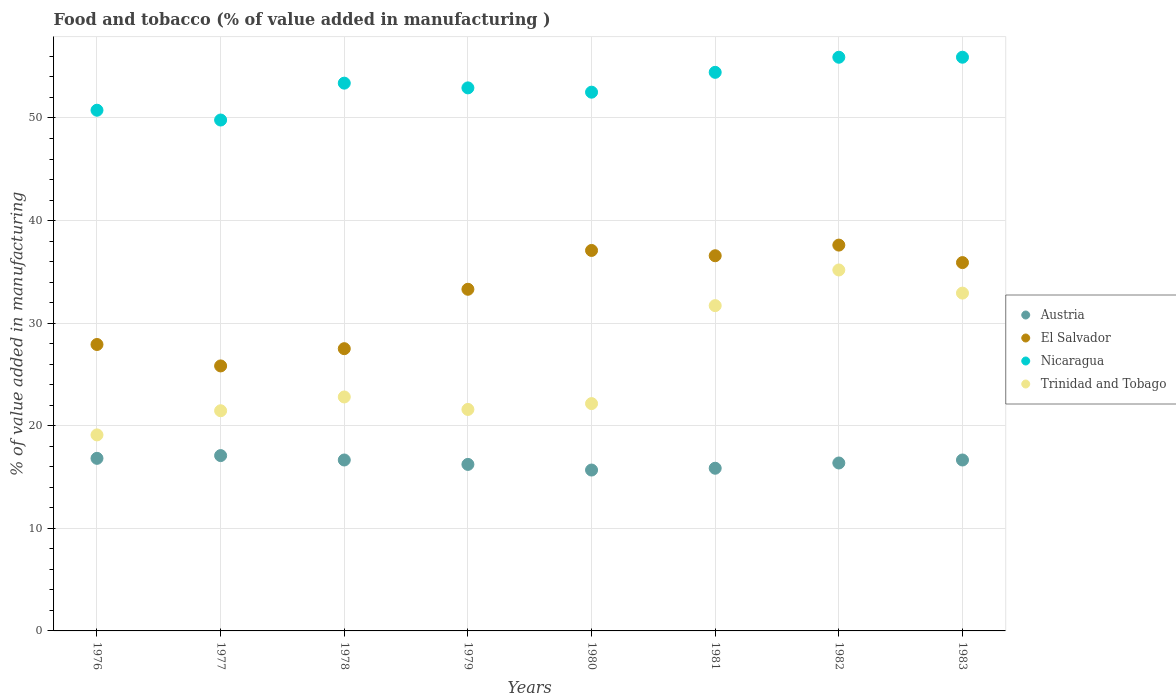How many different coloured dotlines are there?
Ensure brevity in your answer.  4. What is the value added in manufacturing food and tobacco in Austria in 1976?
Provide a short and direct response. 16.82. Across all years, what is the maximum value added in manufacturing food and tobacco in El Salvador?
Your response must be concise. 37.61. Across all years, what is the minimum value added in manufacturing food and tobacco in Nicaragua?
Your answer should be compact. 49.8. What is the total value added in manufacturing food and tobacco in Nicaragua in the graph?
Keep it short and to the point. 425.69. What is the difference between the value added in manufacturing food and tobacco in Austria in 1980 and that in 1983?
Your response must be concise. -0.98. What is the difference between the value added in manufacturing food and tobacco in Austria in 1980 and the value added in manufacturing food and tobacco in El Salvador in 1976?
Make the answer very short. -12.24. What is the average value added in manufacturing food and tobacco in El Salvador per year?
Your answer should be compact. 32.72. In the year 1981, what is the difference between the value added in manufacturing food and tobacco in Austria and value added in manufacturing food and tobacco in Trinidad and Tobago?
Your response must be concise. -15.85. In how many years, is the value added in manufacturing food and tobacco in El Salvador greater than 28 %?
Your response must be concise. 5. What is the ratio of the value added in manufacturing food and tobacco in El Salvador in 1976 to that in 1979?
Your answer should be compact. 0.84. Is the value added in manufacturing food and tobacco in El Salvador in 1981 less than that in 1982?
Make the answer very short. Yes. What is the difference between the highest and the second highest value added in manufacturing food and tobacco in Austria?
Keep it short and to the point. 0.27. What is the difference between the highest and the lowest value added in manufacturing food and tobacco in Austria?
Offer a terse response. 1.41. Is the sum of the value added in manufacturing food and tobacco in Austria in 1982 and 1983 greater than the maximum value added in manufacturing food and tobacco in El Salvador across all years?
Your answer should be compact. No. Does the value added in manufacturing food and tobacco in El Salvador monotonically increase over the years?
Offer a very short reply. No. How many dotlines are there?
Your response must be concise. 4. What is the difference between two consecutive major ticks on the Y-axis?
Your answer should be compact. 10. Are the values on the major ticks of Y-axis written in scientific E-notation?
Your answer should be very brief. No. Does the graph contain grids?
Offer a terse response. Yes. Where does the legend appear in the graph?
Offer a terse response. Center right. How many legend labels are there?
Ensure brevity in your answer.  4. How are the legend labels stacked?
Provide a short and direct response. Vertical. What is the title of the graph?
Your response must be concise. Food and tobacco (% of value added in manufacturing ). What is the label or title of the Y-axis?
Ensure brevity in your answer.  % of value added in manufacturing. What is the % of value added in manufacturing of Austria in 1976?
Ensure brevity in your answer.  16.82. What is the % of value added in manufacturing of El Salvador in 1976?
Provide a succinct answer. 27.92. What is the % of value added in manufacturing of Nicaragua in 1976?
Offer a very short reply. 50.76. What is the % of value added in manufacturing of Trinidad and Tobago in 1976?
Ensure brevity in your answer.  19.11. What is the % of value added in manufacturing of Austria in 1977?
Make the answer very short. 17.09. What is the % of value added in manufacturing in El Salvador in 1977?
Offer a terse response. 25.83. What is the % of value added in manufacturing in Nicaragua in 1977?
Offer a terse response. 49.8. What is the % of value added in manufacturing of Trinidad and Tobago in 1977?
Ensure brevity in your answer.  21.46. What is the % of value added in manufacturing in Austria in 1978?
Your response must be concise. 16.66. What is the % of value added in manufacturing in El Salvador in 1978?
Give a very brief answer. 27.51. What is the % of value added in manufacturing in Nicaragua in 1978?
Offer a very short reply. 53.39. What is the % of value added in manufacturing of Trinidad and Tobago in 1978?
Your answer should be very brief. 22.81. What is the % of value added in manufacturing of Austria in 1979?
Offer a very short reply. 16.23. What is the % of value added in manufacturing of El Salvador in 1979?
Offer a very short reply. 33.3. What is the % of value added in manufacturing in Nicaragua in 1979?
Keep it short and to the point. 52.93. What is the % of value added in manufacturing of Trinidad and Tobago in 1979?
Provide a short and direct response. 21.59. What is the % of value added in manufacturing in Austria in 1980?
Offer a very short reply. 15.68. What is the % of value added in manufacturing in El Salvador in 1980?
Your answer should be very brief. 37.09. What is the % of value added in manufacturing of Nicaragua in 1980?
Provide a short and direct response. 52.51. What is the % of value added in manufacturing of Trinidad and Tobago in 1980?
Your answer should be compact. 22.16. What is the % of value added in manufacturing of Austria in 1981?
Make the answer very short. 15.86. What is the % of value added in manufacturing in El Salvador in 1981?
Provide a succinct answer. 36.57. What is the % of value added in manufacturing in Nicaragua in 1981?
Provide a short and direct response. 54.45. What is the % of value added in manufacturing in Trinidad and Tobago in 1981?
Offer a very short reply. 31.71. What is the % of value added in manufacturing in Austria in 1982?
Provide a succinct answer. 16.37. What is the % of value added in manufacturing in El Salvador in 1982?
Provide a succinct answer. 37.61. What is the % of value added in manufacturing in Nicaragua in 1982?
Keep it short and to the point. 55.92. What is the % of value added in manufacturing of Trinidad and Tobago in 1982?
Your answer should be compact. 35.18. What is the % of value added in manufacturing in Austria in 1983?
Offer a very short reply. 16.66. What is the % of value added in manufacturing in El Salvador in 1983?
Offer a terse response. 35.9. What is the % of value added in manufacturing of Nicaragua in 1983?
Your response must be concise. 55.92. What is the % of value added in manufacturing of Trinidad and Tobago in 1983?
Provide a short and direct response. 32.93. Across all years, what is the maximum % of value added in manufacturing in Austria?
Your answer should be compact. 17.09. Across all years, what is the maximum % of value added in manufacturing of El Salvador?
Provide a short and direct response. 37.61. Across all years, what is the maximum % of value added in manufacturing in Nicaragua?
Your response must be concise. 55.92. Across all years, what is the maximum % of value added in manufacturing of Trinidad and Tobago?
Provide a succinct answer. 35.18. Across all years, what is the minimum % of value added in manufacturing of Austria?
Offer a very short reply. 15.68. Across all years, what is the minimum % of value added in manufacturing of El Salvador?
Keep it short and to the point. 25.83. Across all years, what is the minimum % of value added in manufacturing of Nicaragua?
Offer a very short reply. 49.8. Across all years, what is the minimum % of value added in manufacturing in Trinidad and Tobago?
Give a very brief answer. 19.11. What is the total % of value added in manufacturing of Austria in the graph?
Your response must be concise. 131.38. What is the total % of value added in manufacturing of El Salvador in the graph?
Provide a succinct answer. 261.73. What is the total % of value added in manufacturing in Nicaragua in the graph?
Provide a succinct answer. 425.69. What is the total % of value added in manufacturing in Trinidad and Tobago in the graph?
Provide a succinct answer. 206.94. What is the difference between the % of value added in manufacturing of Austria in 1976 and that in 1977?
Ensure brevity in your answer.  -0.27. What is the difference between the % of value added in manufacturing in El Salvador in 1976 and that in 1977?
Ensure brevity in your answer.  2.09. What is the difference between the % of value added in manufacturing in Nicaragua in 1976 and that in 1977?
Keep it short and to the point. 0.96. What is the difference between the % of value added in manufacturing in Trinidad and Tobago in 1976 and that in 1977?
Give a very brief answer. -2.35. What is the difference between the % of value added in manufacturing of Austria in 1976 and that in 1978?
Ensure brevity in your answer.  0.16. What is the difference between the % of value added in manufacturing in El Salvador in 1976 and that in 1978?
Your answer should be compact. 0.41. What is the difference between the % of value added in manufacturing in Nicaragua in 1976 and that in 1978?
Ensure brevity in your answer.  -2.64. What is the difference between the % of value added in manufacturing of Trinidad and Tobago in 1976 and that in 1978?
Your answer should be very brief. -3.7. What is the difference between the % of value added in manufacturing of Austria in 1976 and that in 1979?
Your response must be concise. 0.59. What is the difference between the % of value added in manufacturing of El Salvador in 1976 and that in 1979?
Your answer should be very brief. -5.38. What is the difference between the % of value added in manufacturing in Nicaragua in 1976 and that in 1979?
Give a very brief answer. -2.18. What is the difference between the % of value added in manufacturing in Trinidad and Tobago in 1976 and that in 1979?
Make the answer very short. -2.48. What is the difference between the % of value added in manufacturing in Austria in 1976 and that in 1980?
Provide a short and direct response. 1.14. What is the difference between the % of value added in manufacturing of El Salvador in 1976 and that in 1980?
Offer a terse response. -9.17. What is the difference between the % of value added in manufacturing in Nicaragua in 1976 and that in 1980?
Your answer should be compact. -1.76. What is the difference between the % of value added in manufacturing in Trinidad and Tobago in 1976 and that in 1980?
Make the answer very short. -3.05. What is the difference between the % of value added in manufacturing of Austria in 1976 and that in 1981?
Ensure brevity in your answer.  0.97. What is the difference between the % of value added in manufacturing of El Salvador in 1976 and that in 1981?
Offer a very short reply. -8.65. What is the difference between the % of value added in manufacturing of Nicaragua in 1976 and that in 1981?
Your response must be concise. -3.69. What is the difference between the % of value added in manufacturing in Trinidad and Tobago in 1976 and that in 1981?
Provide a succinct answer. -12.6. What is the difference between the % of value added in manufacturing of Austria in 1976 and that in 1982?
Ensure brevity in your answer.  0.45. What is the difference between the % of value added in manufacturing of El Salvador in 1976 and that in 1982?
Your answer should be very brief. -9.69. What is the difference between the % of value added in manufacturing in Nicaragua in 1976 and that in 1982?
Keep it short and to the point. -5.16. What is the difference between the % of value added in manufacturing in Trinidad and Tobago in 1976 and that in 1982?
Keep it short and to the point. -16.08. What is the difference between the % of value added in manufacturing of Austria in 1976 and that in 1983?
Provide a short and direct response. 0.16. What is the difference between the % of value added in manufacturing of El Salvador in 1976 and that in 1983?
Keep it short and to the point. -7.98. What is the difference between the % of value added in manufacturing of Nicaragua in 1976 and that in 1983?
Offer a terse response. -5.17. What is the difference between the % of value added in manufacturing in Trinidad and Tobago in 1976 and that in 1983?
Your response must be concise. -13.82. What is the difference between the % of value added in manufacturing in Austria in 1977 and that in 1978?
Offer a terse response. 0.43. What is the difference between the % of value added in manufacturing in El Salvador in 1977 and that in 1978?
Make the answer very short. -1.68. What is the difference between the % of value added in manufacturing in Nicaragua in 1977 and that in 1978?
Provide a succinct answer. -3.59. What is the difference between the % of value added in manufacturing in Trinidad and Tobago in 1977 and that in 1978?
Provide a short and direct response. -1.34. What is the difference between the % of value added in manufacturing of Austria in 1977 and that in 1979?
Offer a terse response. 0.86. What is the difference between the % of value added in manufacturing in El Salvador in 1977 and that in 1979?
Your answer should be very brief. -7.47. What is the difference between the % of value added in manufacturing in Nicaragua in 1977 and that in 1979?
Provide a short and direct response. -3.13. What is the difference between the % of value added in manufacturing of Trinidad and Tobago in 1977 and that in 1979?
Provide a succinct answer. -0.13. What is the difference between the % of value added in manufacturing of Austria in 1977 and that in 1980?
Offer a terse response. 1.41. What is the difference between the % of value added in manufacturing of El Salvador in 1977 and that in 1980?
Offer a terse response. -11.26. What is the difference between the % of value added in manufacturing in Nicaragua in 1977 and that in 1980?
Your answer should be very brief. -2.71. What is the difference between the % of value added in manufacturing of Trinidad and Tobago in 1977 and that in 1980?
Provide a succinct answer. -0.7. What is the difference between the % of value added in manufacturing of Austria in 1977 and that in 1981?
Ensure brevity in your answer.  1.23. What is the difference between the % of value added in manufacturing of El Salvador in 1977 and that in 1981?
Ensure brevity in your answer.  -10.74. What is the difference between the % of value added in manufacturing in Nicaragua in 1977 and that in 1981?
Offer a very short reply. -4.65. What is the difference between the % of value added in manufacturing in Trinidad and Tobago in 1977 and that in 1981?
Offer a very short reply. -10.25. What is the difference between the % of value added in manufacturing in Austria in 1977 and that in 1982?
Your answer should be very brief. 0.72. What is the difference between the % of value added in manufacturing in El Salvador in 1977 and that in 1982?
Give a very brief answer. -11.78. What is the difference between the % of value added in manufacturing of Nicaragua in 1977 and that in 1982?
Your response must be concise. -6.12. What is the difference between the % of value added in manufacturing of Trinidad and Tobago in 1977 and that in 1982?
Your answer should be very brief. -13.72. What is the difference between the % of value added in manufacturing of Austria in 1977 and that in 1983?
Ensure brevity in your answer.  0.43. What is the difference between the % of value added in manufacturing of El Salvador in 1977 and that in 1983?
Make the answer very short. -10.07. What is the difference between the % of value added in manufacturing of Nicaragua in 1977 and that in 1983?
Your answer should be compact. -6.12. What is the difference between the % of value added in manufacturing in Trinidad and Tobago in 1977 and that in 1983?
Your answer should be very brief. -11.47. What is the difference between the % of value added in manufacturing in Austria in 1978 and that in 1979?
Provide a short and direct response. 0.43. What is the difference between the % of value added in manufacturing of El Salvador in 1978 and that in 1979?
Provide a succinct answer. -5.79. What is the difference between the % of value added in manufacturing of Nicaragua in 1978 and that in 1979?
Your response must be concise. 0.46. What is the difference between the % of value added in manufacturing in Trinidad and Tobago in 1978 and that in 1979?
Your response must be concise. 1.22. What is the difference between the % of value added in manufacturing in Austria in 1978 and that in 1980?
Provide a succinct answer. 0.98. What is the difference between the % of value added in manufacturing in El Salvador in 1978 and that in 1980?
Offer a very short reply. -9.57. What is the difference between the % of value added in manufacturing in Nicaragua in 1978 and that in 1980?
Offer a terse response. 0.88. What is the difference between the % of value added in manufacturing of Trinidad and Tobago in 1978 and that in 1980?
Offer a very short reply. 0.65. What is the difference between the % of value added in manufacturing in Austria in 1978 and that in 1981?
Offer a terse response. 0.8. What is the difference between the % of value added in manufacturing in El Salvador in 1978 and that in 1981?
Ensure brevity in your answer.  -9.06. What is the difference between the % of value added in manufacturing in Nicaragua in 1978 and that in 1981?
Ensure brevity in your answer.  -1.05. What is the difference between the % of value added in manufacturing of Trinidad and Tobago in 1978 and that in 1981?
Provide a succinct answer. -8.9. What is the difference between the % of value added in manufacturing in Austria in 1978 and that in 1982?
Keep it short and to the point. 0.29. What is the difference between the % of value added in manufacturing in El Salvador in 1978 and that in 1982?
Ensure brevity in your answer.  -10.1. What is the difference between the % of value added in manufacturing of Nicaragua in 1978 and that in 1982?
Ensure brevity in your answer.  -2.53. What is the difference between the % of value added in manufacturing in Trinidad and Tobago in 1978 and that in 1982?
Ensure brevity in your answer.  -12.38. What is the difference between the % of value added in manufacturing of El Salvador in 1978 and that in 1983?
Keep it short and to the point. -8.39. What is the difference between the % of value added in manufacturing in Nicaragua in 1978 and that in 1983?
Give a very brief answer. -2.53. What is the difference between the % of value added in manufacturing in Trinidad and Tobago in 1978 and that in 1983?
Your response must be concise. -10.12. What is the difference between the % of value added in manufacturing in Austria in 1979 and that in 1980?
Provide a succinct answer. 0.55. What is the difference between the % of value added in manufacturing of El Salvador in 1979 and that in 1980?
Provide a short and direct response. -3.78. What is the difference between the % of value added in manufacturing in Nicaragua in 1979 and that in 1980?
Ensure brevity in your answer.  0.42. What is the difference between the % of value added in manufacturing in Trinidad and Tobago in 1979 and that in 1980?
Offer a terse response. -0.57. What is the difference between the % of value added in manufacturing of Austria in 1979 and that in 1981?
Your answer should be compact. 0.37. What is the difference between the % of value added in manufacturing in El Salvador in 1979 and that in 1981?
Your response must be concise. -3.27. What is the difference between the % of value added in manufacturing of Nicaragua in 1979 and that in 1981?
Provide a succinct answer. -1.52. What is the difference between the % of value added in manufacturing of Trinidad and Tobago in 1979 and that in 1981?
Make the answer very short. -10.12. What is the difference between the % of value added in manufacturing of Austria in 1979 and that in 1982?
Offer a terse response. -0.14. What is the difference between the % of value added in manufacturing of El Salvador in 1979 and that in 1982?
Keep it short and to the point. -4.31. What is the difference between the % of value added in manufacturing in Nicaragua in 1979 and that in 1982?
Offer a very short reply. -2.99. What is the difference between the % of value added in manufacturing in Trinidad and Tobago in 1979 and that in 1982?
Make the answer very short. -13.59. What is the difference between the % of value added in manufacturing in Austria in 1979 and that in 1983?
Provide a short and direct response. -0.43. What is the difference between the % of value added in manufacturing in El Salvador in 1979 and that in 1983?
Offer a terse response. -2.6. What is the difference between the % of value added in manufacturing of Nicaragua in 1979 and that in 1983?
Provide a succinct answer. -2.99. What is the difference between the % of value added in manufacturing in Trinidad and Tobago in 1979 and that in 1983?
Offer a terse response. -11.34. What is the difference between the % of value added in manufacturing of Austria in 1980 and that in 1981?
Keep it short and to the point. -0.18. What is the difference between the % of value added in manufacturing of El Salvador in 1980 and that in 1981?
Your answer should be compact. 0.52. What is the difference between the % of value added in manufacturing of Nicaragua in 1980 and that in 1981?
Offer a very short reply. -1.93. What is the difference between the % of value added in manufacturing in Trinidad and Tobago in 1980 and that in 1981?
Offer a very short reply. -9.55. What is the difference between the % of value added in manufacturing in Austria in 1980 and that in 1982?
Your response must be concise. -0.69. What is the difference between the % of value added in manufacturing of El Salvador in 1980 and that in 1982?
Your answer should be very brief. -0.52. What is the difference between the % of value added in manufacturing in Nicaragua in 1980 and that in 1982?
Your response must be concise. -3.41. What is the difference between the % of value added in manufacturing in Trinidad and Tobago in 1980 and that in 1982?
Provide a succinct answer. -13.02. What is the difference between the % of value added in manufacturing in Austria in 1980 and that in 1983?
Offer a very short reply. -0.98. What is the difference between the % of value added in manufacturing of El Salvador in 1980 and that in 1983?
Provide a succinct answer. 1.18. What is the difference between the % of value added in manufacturing in Nicaragua in 1980 and that in 1983?
Provide a short and direct response. -3.41. What is the difference between the % of value added in manufacturing in Trinidad and Tobago in 1980 and that in 1983?
Provide a short and direct response. -10.77. What is the difference between the % of value added in manufacturing in Austria in 1981 and that in 1982?
Offer a very short reply. -0.51. What is the difference between the % of value added in manufacturing of El Salvador in 1981 and that in 1982?
Provide a short and direct response. -1.04. What is the difference between the % of value added in manufacturing of Nicaragua in 1981 and that in 1982?
Your answer should be very brief. -1.47. What is the difference between the % of value added in manufacturing in Trinidad and Tobago in 1981 and that in 1982?
Keep it short and to the point. -3.48. What is the difference between the % of value added in manufacturing of Austria in 1981 and that in 1983?
Offer a very short reply. -0.8. What is the difference between the % of value added in manufacturing of El Salvador in 1981 and that in 1983?
Offer a terse response. 0.67. What is the difference between the % of value added in manufacturing in Nicaragua in 1981 and that in 1983?
Make the answer very short. -1.47. What is the difference between the % of value added in manufacturing in Trinidad and Tobago in 1981 and that in 1983?
Your answer should be compact. -1.22. What is the difference between the % of value added in manufacturing in Austria in 1982 and that in 1983?
Offer a terse response. -0.29. What is the difference between the % of value added in manufacturing of El Salvador in 1982 and that in 1983?
Make the answer very short. 1.71. What is the difference between the % of value added in manufacturing in Nicaragua in 1982 and that in 1983?
Keep it short and to the point. -0. What is the difference between the % of value added in manufacturing in Trinidad and Tobago in 1982 and that in 1983?
Provide a succinct answer. 2.25. What is the difference between the % of value added in manufacturing in Austria in 1976 and the % of value added in manufacturing in El Salvador in 1977?
Your answer should be very brief. -9.01. What is the difference between the % of value added in manufacturing of Austria in 1976 and the % of value added in manufacturing of Nicaragua in 1977?
Offer a terse response. -32.98. What is the difference between the % of value added in manufacturing in Austria in 1976 and the % of value added in manufacturing in Trinidad and Tobago in 1977?
Your answer should be compact. -4.64. What is the difference between the % of value added in manufacturing in El Salvador in 1976 and the % of value added in manufacturing in Nicaragua in 1977?
Your answer should be compact. -21.88. What is the difference between the % of value added in manufacturing of El Salvador in 1976 and the % of value added in manufacturing of Trinidad and Tobago in 1977?
Make the answer very short. 6.46. What is the difference between the % of value added in manufacturing in Nicaragua in 1976 and the % of value added in manufacturing in Trinidad and Tobago in 1977?
Your response must be concise. 29.29. What is the difference between the % of value added in manufacturing of Austria in 1976 and the % of value added in manufacturing of El Salvador in 1978?
Give a very brief answer. -10.69. What is the difference between the % of value added in manufacturing in Austria in 1976 and the % of value added in manufacturing in Nicaragua in 1978?
Offer a very short reply. -36.57. What is the difference between the % of value added in manufacturing in Austria in 1976 and the % of value added in manufacturing in Trinidad and Tobago in 1978?
Provide a succinct answer. -5.98. What is the difference between the % of value added in manufacturing of El Salvador in 1976 and the % of value added in manufacturing of Nicaragua in 1978?
Your answer should be very brief. -25.47. What is the difference between the % of value added in manufacturing of El Salvador in 1976 and the % of value added in manufacturing of Trinidad and Tobago in 1978?
Provide a succinct answer. 5.11. What is the difference between the % of value added in manufacturing of Nicaragua in 1976 and the % of value added in manufacturing of Trinidad and Tobago in 1978?
Offer a terse response. 27.95. What is the difference between the % of value added in manufacturing of Austria in 1976 and the % of value added in manufacturing of El Salvador in 1979?
Keep it short and to the point. -16.48. What is the difference between the % of value added in manufacturing in Austria in 1976 and the % of value added in manufacturing in Nicaragua in 1979?
Your response must be concise. -36.11. What is the difference between the % of value added in manufacturing of Austria in 1976 and the % of value added in manufacturing of Trinidad and Tobago in 1979?
Your response must be concise. -4.77. What is the difference between the % of value added in manufacturing in El Salvador in 1976 and the % of value added in manufacturing in Nicaragua in 1979?
Offer a very short reply. -25.01. What is the difference between the % of value added in manufacturing of El Salvador in 1976 and the % of value added in manufacturing of Trinidad and Tobago in 1979?
Offer a very short reply. 6.33. What is the difference between the % of value added in manufacturing of Nicaragua in 1976 and the % of value added in manufacturing of Trinidad and Tobago in 1979?
Provide a succinct answer. 29.17. What is the difference between the % of value added in manufacturing in Austria in 1976 and the % of value added in manufacturing in El Salvador in 1980?
Offer a terse response. -20.26. What is the difference between the % of value added in manufacturing of Austria in 1976 and the % of value added in manufacturing of Nicaragua in 1980?
Your response must be concise. -35.69. What is the difference between the % of value added in manufacturing of Austria in 1976 and the % of value added in manufacturing of Trinidad and Tobago in 1980?
Keep it short and to the point. -5.34. What is the difference between the % of value added in manufacturing in El Salvador in 1976 and the % of value added in manufacturing in Nicaragua in 1980?
Offer a very short reply. -24.59. What is the difference between the % of value added in manufacturing of El Salvador in 1976 and the % of value added in manufacturing of Trinidad and Tobago in 1980?
Make the answer very short. 5.76. What is the difference between the % of value added in manufacturing in Nicaragua in 1976 and the % of value added in manufacturing in Trinidad and Tobago in 1980?
Ensure brevity in your answer.  28.6. What is the difference between the % of value added in manufacturing of Austria in 1976 and the % of value added in manufacturing of El Salvador in 1981?
Your answer should be very brief. -19.75. What is the difference between the % of value added in manufacturing of Austria in 1976 and the % of value added in manufacturing of Nicaragua in 1981?
Keep it short and to the point. -37.63. What is the difference between the % of value added in manufacturing of Austria in 1976 and the % of value added in manufacturing of Trinidad and Tobago in 1981?
Keep it short and to the point. -14.88. What is the difference between the % of value added in manufacturing in El Salvador in 1976 and the % of value added in manufacturing in Nicaragua in 1981?
Offer a very short reply. -26.53. What is the difference between the % of value added in manufacturing of El Salvador in 1976 and the % of value added in manufacturing of Trinidad and Tobago in 1981?
Your answer should be compact. -3.79. What is the difference between the % of value added in manufacturing in Nicaragua in 1976 and the % of value added in manufacturing in Trinidad and Tobago in 1981?
Your answer should be compact. 19.05. What is the difference between the % of value added in manufacturing of Austria in 1976 and the % of value added in manufacturing of El Salvador in 1982?
Provide a short and direct response. -20.79. What is the difference between the % of value added in manufacturing of Austria in 1976 and the % of value added in manufacturing of Nicaragua in 1982?
Provide a short and direct response. -39.1. What is the difference between the % of value added in manufacturing in Austria in 1976 and the % of value added in manufacturing in Trinidad and Tobago in 1982?
Your answer should be compact. -18.36. What is the difference between the % of value added in manufacturing in El Salvador in 1976 and the % of value added in manufacturing in Nicaragua in 1982?
Keep it short and to the point. -28. What is the difference between the % of value added in manufacturing of El Salvador in 1976 and the % of value added in manufacturing of Trinidad and Tobago in 1982?
Your answer should be compact. -7.26. What is the difference between the % of value added in manufacturing in Nicaragua in 1976 and the % of value added in manufacturing in Trinidad and Tobago in 1982?
Give a very brief answer. 15.57. What is the difference between the % of value added in manufacturing in Austria in 1976 and the % of value added in manufacturing in El Salvador in 1983?
Offer a very short reply. -19.08. What is the difference between the % of value added in manufacturing in Austria in 1976 and the % of value added in manufacturing in Nicaragua in 1983?
Make the answer very short. -39.1. What is the difference between the % of value added in manufacturing in Austria in 1976 and the % of value added in manufacturing in Trinidad and Tobago in 1983?
Provide a succinct answer. -16.11. What is the difference between the % of value added in manufacturing in El Salvador in 1976 and the % of value added in manufacturing in Nicaragua in 1983?
Your response must be concise. -28. What is the difference between the % of value added in manufacturing of El Salvador in 1976 and the % of value added in manufacturing of Trinidad and Tobago in 1983?
Provide a succinct answer. -5.01. What is the difference between the % of value added in manufacturing of Nicaragua in 1976 and the % of value added in manufacturing of Trinidad and Tobago in 1983?
Your answer should be very brief. 17.83. What is the difference between the % of value added in manufacturing of Austria in 1977 and the % of value added in manufacturing of El Salvador in 1978?
Your answer should be very brief. -10.42. What is the difference between the % of value added in manufacturing of Austria in 1977 and the % of value added in manufacturing of Nicaragua in 1978?
Your response must be concise. -36.3. What is the difference between the % of value added in manufacturing of Austria in 1977 and the % of value added in manufacturing of Trinidad and Tobago in 1978?
Offer a terse response. -5.72. What is the difference between the % of value added in manufacturing of El Salvador in 1977 and the % of value added in manufacturing of Nicaragua in 1978?
Your answer should be very brief. -27.56. What is the difference between the % of value added in manufacturing in El Salvador in 1977 and the % of value added in manufacturing in Trinidad and Tobago in 1978?
Your response must be concise. 3.03. What is the difference between the % of value added in manufacturing in Nicaragua in 1977 and the % of value added in manufacturing in Trinidad and Tobago in 1978?
Your answer should be compact. 26.99. What is the difference between the % of value added in manufacturing of Austria in 1977 and the % of value added in manufacturing of El Salvador in 1979?
Offer a terse response. -16.21. What is the difference between the % of value added in manufacturing of Austria in 1977 and the % of value added in manufacturing of Nicaragua in 1979?
Your answer should be compact. -35.84. What is the difference between the % of value added in manufacturing in Austria in 1977 and the % of value added in manufacturing in Trinidad and Tobago in 1979?
Provide a short and direct response. -4.5. What is the difference between the % of value added in manufacturing in El Salvador in 1977 and the % of value added in manufacturing in Nicaragua in 1979?
Give a very brief answer. -27.1. What is the difference between the % of value added in manufacturing of El Salvador in 1977 and the % of value added in manufacturing of Trinidad and Tobago in 1979?
Offer a terse response. 4.24. What is the difference between the % of value added in manufacturing in Nicaragua in 1977 and the % of value added in manufacturing in Trinidad and Tobago in 1979?
Your answer should be very brief. 28.21. What is the difference between the % of value added in manufacturing in Austria in 1977 and the % of value added in manufacturing in El Salvador in 1980?
Keep it short and to the point. -20. What is the difference between the % of value added in manufacturing in Austria in 1977 and the % of value added in manufacturing in Nicaragua in 1980?
Provide a short and direct response. -35.42. What is the difference between the % of value added in manufacturing in Austria in 1977 and the % of value added in manufacturing in Trinidad and Tobago in 1980?
Give a very brief answer. -5.07. What is the difference between the % of value added in manufacturing of El Salvador in 1977 and the % of value added in manufacturing of Nicaragua in 1980?
Keep it short and to the point. -26.68. What is the difference between the % of value added in manufacturing of El Salvador in 1977 and the % of value added in manufacturing of Trinidad and Tobago in 1980?
Offer a terse response. 3.67. What is the difference between the % of value added in manufacturing of Nicaragua in 1977 and the % of value added in manufacturing of Trinidad and Tobago in 1980?
Your answer should be very brief. 27.64. What is the difference between the % of value added in manufacturing of Austria in 1977 and the % of value added in manufacturing of El Salvador in 1981?
Offer a very short reply. -19.48. What is the difference between the % of value added in manufacturing in Austria in 1977 and the % of value added in manufacturing in Nicaragua in 1981?
Make the answer very short. -37.36. What is the difference between the % of value added in manufacturing in Austria in 1977 and the % of value added in manufacturing in Trinidad and Tobago in 1981?
Keep it short and to the point. -14.62. What is the difference between the % of value added in manufacturing in El Salvador in 1977 and the % of value added in manufacturing in Nicaragua in 1981?
Ensure brevity in your answer.  -28.62. What is the difference between the % of value added in manufacturing of El Salvador in 1977 and the % of value added in manufacturing of Trinidad and Tobago in 1981?
Offer a terse response. -5.88. What is the difference between the % of value added in manufacturing of Nicaragua in 1977 and the % of value added in manufacturing of Trinidad and Tobago in 1981?
Ensure brevity in your answer.  18.09. What is the difference between the % of value added in manufacturing of Austria in 1977 and the % of value added in manufacturing of El Salvador in 1982?
Provide a succinct answer. -20.52. What is the difference between the % of value added in manufacturing in Austria in 1977 and the % of value added in manufacturing in Nicaragua in 1982?
Keep it short and to the point. -38.83. What is the difference between the % of value added in manufacturing in Austria in 1977 and the % of value added in manufacturing in Trinidad and Tobago in 1982?
Offer a very short reply. -18.09. What is the difference between the % of value added in manufacturing of El Salvador in 1977 and the % of value added in manufacturing of Nicaragua in 1982?
Your answer should be very brief. -30.09. What is the difference between the % of value added in manufacturing of El Salvador in 1977 and the % of value added in manufacturing of Trinidad and Tobago in 1982?
Make the answer very short. -9.35. What is the difference between the % of value added in manufacturing of Nicaragua in 1977 and the % of value added in manufacturing of Trinidad and Tobago in 1982?
Give a very brief answer. 14.62. What is the difference between the % of value added in manufacturing of Austria in 1977 and the % of value added in manufacturing of El Salvador in 1983?
Keep it short and to the point. -18.81. What is the difference between the % of value added in manufacturing of Austria in 1977 and the % of value added in manufacturing of Nicaragua in 1983?
Your answer should be very brief. -38.83. What is the difference between the % of value added in manufacturing of Austria in 1977 and the % of value added in manufacturing of Trinidad and Tobago in 1983?
Your answer should be very brief. -15.84. What is the difference between the % of value added in manufacturing in El Salvador in 1977 and the % of value added in manufacturing in Nicaragua in 1983?
Ensure brevity in your answer.  -30.09. What is the difference between the % of value added in manufacturing of El Salvador in 1977 and the % of value added in manufacturing of Trinidad and Tobago in 1983?
Your answer should be very brief. -7.1. What is the difference between the % of value added in manufacturing of Nicaragua in 1977 and the % of value added in manufacturing of Trinidad and Tobago in 1983?
Ensure brevity in your answer.  16.87. What is the difference between the % of value added in manufacturing of Austria in 1978 and the % of value added in manufacturing of El Salvador in 1979?
Your answer should be very brief. -16.64. What is the difference between the % of value added in manufacturing in Austria in 1978 and the % of value added in manufacturing in Nicaragua in 1979?
Keep it short and to the point. -36.27. What is the difference between the % of value added in manufacturing in Austria in 1978 and the % of value added in manufacturing in Trinidad and Tobago in 1979?
Provide a succinct answer. -4.93. What is the difference between the % of value added in manufacturing of El Salvador in 1978 and the % of value added in manufacturing of Nicaragua in 1979?
Ensure brevity in your answer.  -25.42. What is the difference between the % of value added in manufacturing in El Salvador in 1978 and the % of value added in manufacturing in Trinidad and Tobago in 1979?
Your response must be concise. 5.92. What is the difference between the % of value added in manufacturing in Nicaragua in 1978 and the % of value added in manufacturing in Trinidad and Tobago in 1979?
Keep it short and to the point. 31.81. What is the difference between the % of value added in manufacturing in Austria in 1978 and the % of value added in manufacturing in El Salvador in 1980?
Give a very brief answer. -20.43. What is the difference between the % of value added in manufacturing of Austria in 1978 and the % of value added in manufacturing of Nicaragua in 1980?
Offer a very short reply. -35.85. What is the difference between the % of value added in manufacturing in Austria in 1978 and the % of value added in manufacturing in Trinidad and Tobago in 1980?
Give a very brief answer. -5.5. What is the difference between the % of value added in manufacturing in El Salvador in 1978 and the % of value added in manufacturing in Nicaragua in 1980?
Provide a succinct answer. -25. What is the difference between the % of value added in manufacturing in El Salvador in 1978 and the % of value added in manufacturing in Trinidad and Tobago in 1980?
Offer a very short reply. 5.35. What is the difference between the % of value added in manufacturing of Nicaragua in 1978 and the % of value added in manufacturing of Trinidad and Tobago in 1980?
Your answer should be compact. 31.24. What is the difference between the % of value added in manufacturing of Austria in 1978 and the % of value added in manufacturing of El Salvador in 1981?
Offer a very short reply. -19.91. What is the difference between the % of value added in manufacturing of Austria in 1978 and the % of value added in manufacturing of Nicaragua in 1981?
Your answer should be very brief. -37.79. What is the difference between the % of value added in manufacturing of Austria in 1978 and the % of value added in manufacturing of Trinidad and Tobago in 1981?
Your response must be concise. -15.05. What is the difference between the % of value added in manufacturing in El Salvador in 1978 and the % of value added in manufacturing in Nicaragua in 1981?
Provide a short and direct response. -26.94. What is the difference between the % of value added in manufacturing of El Salvador in 1978 and the % of value added in manufacturing of Trinidad and Tobago in 1981?
Give a very brief answer. -4.2. What is the difference between the % of value added in manufacturing of Nicaragua in 1978 and the % of value added in manufacturing of Trinidad and Tobago in 1981?
Give a very brief answer. 21.69. What is the difference between the % of value added in manufacturing in Austria in 1978 and the % of value added in manufacturing in El Salvador in 1982?
Provide a short and direct response. -20.95. What is the difference between the % of value added in manufacturing of Austria in 1978 and the % of value added in manufacturing of Nicaragua in 1982?
Offer a terse response. -39.26. What is the difference between the % of value added in manufacturing of Austria in 1978 and the % of value added in manufacturing of Trinidad and Tobago in 1982?
Your answer should be very brief. -18.52. What is the difference between the % of value added in manufacturing in El Salvador in 1978 and the % of value added in manufacturing in Nicaragua in 1982?
Your response must be concise. -28.41. What is the difference between the % of value added in manufacturing in El Salvador in 1978 and the % of value added in manufacturing in Trinidad and Tobago in 1982?
Offer a very short reply. -7.67. What is the difference between the % of value added in manufacturing of Nicaragua in 1978 and the % of value added in manufacturing of Trinidad and Tobago in 1982?
Keep it short and to the point. 18.21. What is the difference between the % of value added in manufacturing of Austria in 1978 and the % of value added in manufacturing of El Salvador in 1983?
Keep it short and to the point. -19.24. What is the difference between the % of value added in manufacturing of Austria in 1978 and the % of value added in manufacturing of Nicaragua in 1983?
Keep it short and to the point. -39.26. What is the difference between the % of value added in manufacturing in Austria in 1978 and the % of value added in manufacturing in Trinidad and Tobago in 1983?
Your answer should be compact. -16.27. What is the difference between the % of value added in manufacturing in El Salvador in 1978 and the % of value added in manufacturing in Nicaragua in 1983?
Offer a very short reply. -28.41. What is the difference between the % of value added in manufacturing in El Salvador in 1978 and the % of value added in manufacturing in Trinidad and Tobago in 1983?
Give a very brief answer. -5.42. What is the difference between the % of value added in manufacturing in Nicaragua in 1978 and the % of value added in manufacturing in Trinidad and Tobago in 1983?
Make the answer very short. 20.47. What is the difference between the % of value added in manufacturing of Austria in 1979 and the % of value added in manufacturing of El Salvador in 1980?
Your answer should be compact. -20.86. What is the difference between the % of value added in manufacturing in Austria in 1979 and the % of value added in manufacturing in Nicaragua in 1980?
Offer a very short reply. -36.28. What is the difference between the % of value added in manufacturing in Austria in 1979 and the % of value added in manufacturing in Trinidad and Tobago in 1980?
Make the answer very short. -5.93. What is the difference between the % of value added in manufacturing in El Salvador in 1979 and the % of value added in manufacturing in Nicaragua in 1980?
Keep it short and to the point. -19.21. What is the difference between the % of value added in manufacturing in El Salvador in 1979 and the % of value added in manufacturing in Trinidad and Tobago in 1980?
Keep it short and to the point. 11.14. What is the difference between the % of value added in manufacturing in Nicaragua in 1979 and the % of value added in manufacturing in Trinidad and Tobago in 1980?
Offer a terse response. 30.77. What is the difference between the % of value added in manufacturing of Austria in 1979 and the % of value added in manufacturing of El Salvador in 1981?
Offer a very short reply. -20.34. What is the difference between the % of value added in manufacturing of Austria in 1979 and the % of value added in manufacturing of Nicaragua in 1981?
Provide a short and direct response. -38.22. What is the difference between the % of value added in manufacturing in Austria in 1979 and the % of value added in manufacturing in Trinidad and Tobago in 1981?
Offer a very short reply. -15.48. What is the difference between the % of value added in manufacturing in El Salvador in 1979 and the % of value added in manufacturing in Nicaragua in 1981?
Your answer should be compact. -21.15. What is the difference between the % of value added in manufacturing of El Salvador in 1979 and the % of value added in manufacturing of Trinidad and Tobago in 1981?
Ensure brevity in your answer.  1.6. What is the difference between the % of value added in manufacturing of Nicaragua in 1979 and the % of value added in manufacturing of Trinidad and Tobago in 1981?
Make the answer very short. 21.23. What is the difference between the % of value added in manufacturing in Austria in 1979 and the % of value added in manufacturing in El Salvador in 1982?
Provide a succinct answer. -21.38. What is the difference between the % of value added in manufacturing in Austria in 1979 and the % of value added in manufacturing in Nicaragua in 1982?
Keep it short and to the point. -39.69. What is the difference between the % of value added in manufacturing of Austria in 1979 and the % of value added in manufacturing of Trinidad and Tobago in 1982?
Keep it short and to the point. -18.95. What is the difference between the % of value added in manufacturing of El Salvador in 1979 and the % of value added in manufacturing of Nicaragua in 1982?
Your answer should be very brief. -22.62. What is the difference between the % of value added in manufacturing of El Salvador in 1979 and the % of value added in manufacturing of Trinidad and Tobago in 1982?
Keep it short and to the point. -1.88. What is the difference between the % of value added in manufacturing in Nicaragua in 1979 and the % of value added in manufacturing in Trinidad and Tobago in 1982?
Provide a short and direct response. 17.75. What is the difference between the % of value added in manufacturing of Austria in 1979 and the % of value added in manufacturing of El Salvador in 1983?
Your answer should be compact. -19.67. What is the difference between the % of value added in manufacturing in Austria in 1979 and the % of value added in manufacturing in Nicaragua in 1983?
Offer a terse response. -39.69. What is the difference between the % of value added in manufacturing of Austria in 1979 and the % of value added in manufacturing of Trinidad and Tobago in 1983?
Keep it short and to the point. -16.7. What is the difference between the % of value added in manufacturing in El Salvador in 1979 and the % of value added in manufacturing in Nicaragua in 1983?
Offer a very short reply. -22.62. What is the difference between the % of value added in manufacturing of El Salvador in 1979 and the % of value added in manufacturing of Trinidad and Tobago in 1983?
Provide a succinct answer. 0.37. What is the difference between the % of value added in manufacturing of Nicaragua in 1979 and the % of value added in manufacturing of Trinidad and Tobago in 1983?
Your answer should be very brief. 20. What is the difference between the % of value added in manufacturing of Austria in 1980 and the % of value added in manufacturing of El Salvador in 1981?
Provide a short and direct response. -20.89. What is the difference between the % of value added in manufacturing in Austria in 1980 and the % of value added in manufacturing in Nicaragua in 1981?
Ensure brevity in your answer.  -38.77. What is the difference between the % of value added in manufacturing in Austria in 1980 and the % of value added in manufacturing in Trinidad and Tobago in 1981?
Offer a terse response. -16.03. What is the difference between the % of value added in manufacturing of El Salvador in 1980 and the % of value added in manufacturing of Nicaragua in 1981?
Give a very brief answer. -17.36. What is the difference between the % of value added in manufacturing of El Salvador in 1980 and the % of value added in manufacturing of Trinidad and Tobago in 1981?
Give a very brief answer. 5.38. What is the difference between the % of value added in manufacturing of Nicaragua in 1980 and the % of value added in manufacturing of Trinidad and Tobago in 1981?
Give a very brief answer. 20.81. What is the difference between the % of value added in manufacturing in Austria in 1980 and the % of value added in manufacturing in El Salvador in 1982?
Make the answer very short. -21.93. What is the difference between the % of value added in manufacturing in Austria in 1980 and the % of value added in manufacturing in Nicaragua in 1982?
Your response must be concise. -40.24. What is the difference between the % of value added in manufacturing in Austria in 1980 and the % of value added in manufacturing in Trinidad and Tobago in 1982?
Your answer should be compact. -19.5. What is the difference between the % of value added in manufacturing in El Salvador in 1980 and the % of value added in manufacturing in Nicaragua in 1982?
Make the answer very short. -18.83. What is the difference between the % of value added in manufacturing in El Salvador in 1980 and the % of value added in manufacturing in Trinidad and Tobago in 1982?
Your answer should be compact. 1.9. What is the difference between the % of value added in manufacturing of Nicaragua in 1980 and the % of value added in manufacturing of Trinidad and Tobago in 1982?
Provide a succinct answer. 17.33. What is the difference between the % of value added in manufacturing of Austria in 1980 and the % of value added in manufacturing of El Salvador in 1983?
Offer a very short reply. -20.22. What is the difference between the % of value added in manufacturing of Austria in 1980 and the % of value added in manufacturing of Nicaragua in 1983?
Offer a very short reply. -40.24. What is the difference between the % of value added in manufacturing in Austria in 1980 and the % of value added in manufacturing in Trinidad and Tobago in 1983?
Give a very brief answer. -17.25. What is the difference between the % of value added in manufacturing in El Salvador in 1980 and the % of value added in manufacturing in Nicaragua in 1983?
Your answer should be compact. -18.84. What is the difference between the % of value added in manufacturing in El Salvador in 1980 and the % of value added in manufacturing in Trinidad and Tobago in 1983?
Offer a very short reply. 4.16. What is the difference between the % of value added in manufacturing in Nicaragua in 1980 and the % of value added in manufacturing in Trinidad and Tobago in 1983?
Offer a very short reply. 19.59. What is the difference between the % of value added in manufacturing of Austria in 1981 and the % of value added in manufacturing of El Salvador in 1982?
Offer a terse response. -21.75. What is the difference between the % of value added in manufacturing of Austria in 1981 and the % of value added in manufacturing of Nicaragua in 1982?
Your answer should be very brief. -40.06. What is the difference between the % of value added in manufacturing of Austria in 1981 and the % of value added in manufacturing of Trinidad and Tobago in 1982?
Give a very brief answer. -19.33. What is the difference between the % of value added in manufacturing of El Salvador in 1981 and the % of value added in manufacturing of Nicaragua in 1982?
Ensure brevity in your answer.  -19.35. What is the difference between the % of value added in manufacturing of El Salvador in 1981 and the % of value added in manufacturing of Trinidad and Tobago in 1982?
Ensure brevity in your answer.  1.39. What is the difference between the % of value added in manufacturing in Nicaragua in 1981 and the % of value added in manufacturing in Trinidad and Tobago in 1982?
Your answer should be compact. 19.27. What is the difference between the % of value added in manufacturing in Austria in 1981 and the % of value added in manufacturing in El Salvador in 1983?
Offer a very short reply. -20.04. What is the difference between the % of value added in manufacturing of Austria in 1981 and the % of value added in manufacturing of Nicaragua in 1983?
Give a very brief answer. -40.06. What is the difference between the % of value added in manufacturing in Austria in 1981 and the % of value added in manufacturing in Trinidad and Tobago in 1983?
Provide a succinct answer. -17.07. What is the difference between the % of value added in manufacturing in El Salvador in 1981 and the % of value added in manufacturing in Nicaragua in 1983?
Make the answer very short. -19.35. What is the difference between the % of value added in manufacturing in El Salvador in 1981 and the % of value added in manufacturing in Trinidad and Tobago in 1983?
Offer a very short reply. 3.64. What is the difference between the % of value added in manufacturing of Nicaragua in 1981 and the % of value added in manufacturing of Trinidad and Tobago in 1983?
Your answer should be compact. 21.52. What is the difference between the % of value added in manufacturing of Austria in 1982 and the % of value added in manufacturing of El Salvador in 1983?
Offer a very short reply. -19.53. What is the difference between the % of value added in manufacturing of Austria in 1982 and the % of value added in manufacturing of Nicaragua in 1983?
Offer a terse response. -39.55. What is the difference between the % of value added in manufacturing of Austria in 1982 and the % of value added in manufacturing of Trinidad and Tobago in 1983?
Make the answer very short. -16.56. What is the difference between the % of value added in manufacturing in El Salvador in 1982 and the % of value added in manufacturing in Nicaragua in 1983?
Give a very brief answer. -18.31. What is the difference between the % of value added in manufacturing of El Salvador in 1982 and the % of value added in manufacturing of Trinidad and Tobago in 1983?
Keep it short and to the point. 4.68. What is the difference between the % of value added in manufacturing in Nicaragua in 1982 and the % of value added in manufacturing in Trinidad and Tobago in 1983?
Make the answer very short. 22.99. What is the average % of value added in manufacturing in Austria per year?
Offer a terse response. 16.42. What is the average % of value added in manufacturing of El Salvador per year?
Keep it short and to the point. 32.72. What is the average % of value added in manufacturing in Nicaragua per year?
Keep it short and to the point. 53.21. What is the average % of value added in manufacturing in Trinidad and Tobago per year?
Your answer should be compact. 25.87. In the year 1976, what is the difference between the % of value added in manufacturing in Austria and % of value added in manufacturing in El Salvador?
Make the answer very short. -11.1. In the year 1976, what is the difference between the % of value added in manufacturing of Austria and % of value added in manufacturing of Nicaragua?
Provide a short and direct response. -33.93. In the year 1976, what is the difference between the % of value added in manufacturing in Austria and % of value added in manufacturing in Trinidad and Tobago?
Offer a terse response. -2.28. In the year 1976, what is the difference between the % of value added in manufacturing in El Salvador and % of value added in manufacturing in Nicaragua?
Ensure brevity in your answer.  -22.84. In the year 1976, what is the difference between the % of value added in manufacturing of El Salvador and % of value added in manufacturing of Trinidad and Tobago?
Your answer should be compact. 8.81. In the year 1976, what is the difference between the % of value added in manufacturing of Nicaragua and % of value added in manufacturing of Trinidad and Tobago?
Keep it short and to the point. 31.65. In the year 1977, what is the difference between the % of value added in manufacturing of Austria and % of value added in manufacturing of El Salvador?
Keep it short and to the point. -8.74. In the year 1977, what is the difference between the % of value added in manufacturing in Austria and % of value added in manufacturing in Nicaragua?
Offer a terse response. -32.71. In the year 1977, what is the difference between the % of value added in manufacturing of Austria and % of value added in manufacturing of Trinidad and Tobago?
Your answer should be very brief. -4.37. In the year 1977, what is the difference between the % of value added in manufacturing of El Salvador and % of value added in manufacturing of Nicaragua?
Your answer should be compact. -23.97. In the year 1977, what is the difference between the % of value added in manufacturing in El Salvador and % of value added in manufacturing in Trinidad and Tobago?
Ensure brevity in your answer.  4.37. In the year 1977, what is the difference between the % of value added in manufacturing in Nicaragua and % of value added in manufacturing in Trinidad and Tobago?
Offer a terse response. 28.34. In the year 1978, what is the difference between the % of value added in manufacturing of Austria and % of value added in manufacturing of El Salvador?
Your answer should be compact. -10.85. In the year 1978, what is the difference between the % of value added in manufacturing in Austria and % of value added in manufacturing in Nicaragua?
Give a very brief answer. -36.73. In the year 1978, what is the difference between the % of value added in manufacturing of Austria and % of value added in manufacturing of Trinidad and Tobago?
Your answer should be very brief. -6.14. In the year 1978, what is the difference between the % of value added in manufacturing of El Salvador and % of value added in manufacturing of Nicaragua?
Keep it short and to the point. -25.88. In the year 1978, what is the difference between the % of value added in manufacturing of El Salvador and % of value added in manufacturing of Trinidad and Tobago?
Offer a very short reply. 4.71. In the year 1978, what is the difference between the % of value added in manufacturing in Nicaragua and % of value added in manufacturing in Trinidad and Tobago?
Ensure brevity in your answer.  30.59. In the year 1979, what is the difference between the % of value added in manufacturing of Austria and % of value added in manufacturing of El Salvador?
Provide a succinct answer. -17.07. In the year 1979, what is the difference between the % of value added in manufacturing of Austria and % of value added in manufacturing of Nicaragua?
Your answer should be compact. -36.7. In the year 1979, what is the difference between the % of value added in manufacturing in Austria and % of value added in manufacturing in Trinidad and Tobago?
Your answer should be compact. -5.36. In the year 1979, what is the difference between the % of value added in manufacturing in El Salvador and % of value added in manufacturing in Nicaragua?
Your answer should be compact. -19.63. In the year 1979, what is the difference between the % of value added in manufacturing in El Salvador and % of value added in manufacturing in Trinidad and Tobago?
Provide a succinct answer. 11.71. In the year 1979, what is the difference between the % of value added in manufacturing in Nicaragua and % of value added in manufacturing in Trinidad and Tobago?
Provide a short and direct response. 31.34. In the year 1980, what is the difference between the % of value added in manufacturing of Austria and % of value added in manufacturing of El Salvador?
Your answer should be very brief. -21.4. In the year 1980, what is the difference between the % of value added in manufacturing in Austria and % of value added in manufacturing in Nicaragua?
Your answer should be compact. -36.83. In the year 1980, what is the difference between the % of value added in manufacturing in Austria and % of value added in manufacturing in Trinidad and Tobago?
Your answer should be very brief. -6.48. In the year 1980, what is the difference between the % of value added in manufacturing in El Salvador and % of value added in manufacturing in Nicaragua?
Your answer should be compact. -15.43. In the year 1980, what is the difference between the % of value added in manufacturing of El Salvador and % of value added in manufacturing of Trinidad and Tobago?
Make the answer very short. 14.93. In the year 1980, what is the difference between the % of value added in manufacturing of Nicaragua and % of value added in manufacturing of Trinidad and Tobago?
Offer a terse response. 30.36. In the year 1981, what is the difference between the % of value added in manufacturing in Austria and % of value added in manufacturing in El Salvador?
Your answer should be compact. -20.71. In the year 1981, what is the difference between the % of value added in manufacturing in Austria and % of value added in manufacturing in Nicaragua?
Your answer should be very brief. -38.59. In the year 1981, what is the difference between the % of value added in manufacturing in Austria and % of value added in manufacturing in Trinidad and Tobago?
Ensure brevity in your answer.  -15.85. In the year 1981, what is the difference between the % of value added in manufacturing of El Salvador and % of value added in manufacturing of Nicaragua?
Your answer should be very brief. -17.88. In the year 1981, what is the difference between the % of value added in manufacturing in El Salvador and % of value added in manufacturing in Trinidad and Tobago?
Your response must be concise. 4.86. In the year 1981, what is the difference between the % of value added in manufacturing in Nicaragua and % of value added in manufacturing in Trinidad and Tobago?
Offer a very short reply. 22.74. In the year 1982, what is the difference between the % of value added in manufacturing of Austria and % of value added in manufacturing of El Salvador?
Your answer should be very brief. -21.24. In the year 1982, what is the difference between the % of value added in manufacturing of Austria and % of value added in manufacturing of Nicaragua?
Give a very brief answer. -39.55. In the year 1982, what is the difference between the % of value added in manufacturing of Austria and % of value added in manufacturing of Trinidad and Tobago?
Give a very brief answer. -18.81. In the year 1982, what is the difference between the % of value added in manufacturing of El Salvador and % of value added in manufacturing of Nicaragua?
Offer a terse response. -18.31. In the year 1982, what is the difference between the % of value added in manufacturing of El Salvador and % of value added in manufacturing of Trinidad and Tobago?
Your response must be concise. 2.43. In the year 1982, what is the difference between the % of value added in manufacturing of Nicaragua and % of value added in manufacturing of Trinidad and Tobago?
Your response must be concise. 20.74. In the year 1983, what is the difference between the % of value added in manufacturing of Austria and % of value added in manufacturing of El Salvador?
Your answer should be very brief. -19.24. In the year 1983, what is the difference between the % of value added in manufacturing of Austria and % of value added in manufacturing of Nicaragua?
Make the answer very short. -39.26. In the year 1983, what is the difference between the % of value added in manufacturing of Austria and % of value added in manufacturing of Trinidad and Tobago?
Your answer should be compact. -16.27. In the year 1983, what is the difference between the % of value added in manufacturing in El Salvador and % of value added in manufacturing in Nicaragua?
Make the answer very short. -20.02. In the year 1983, what is the difference between the % of value added in manufacturing in El Salvador and % of value added in manufacturing in Trinidad and Tobago?
Offer a very short reply. 2.97. In the year 1983, what is the difference between the % of value added in manufacturing of Nicaragua and % of value added in manufacturing of Trinidad and Tobago?
Provide a succinct answer. 22.99. What is the ratio of the % of value added in manufacturing in Austria in 1976 to that in 1977?
Your answer should be very brief. 0.98. What is the ratio of the % of value added in manufacturing in El Salvador in 1976 to that in 1977?
Your answer should be very brief. 1.08. What is the ratio of the % of value added in manufacturing of Nicaragua in 1976 to that in 1977?
Ensure brevity in your answer.  1.02. What is the ratio of the % of value added in manufacturing in Trinidad and Tobago in 1976 to that in 1977?
Ensure brevity in your answer.  0.89. What is the ratio of the % of value added in manufacturing in Austria in 1976 to that in 1978?
Provide a short and direct response. 1.01. What is the ratio of the % of value added in manufacturing in El Salvador in 1976 to that in 1978?
Your response must be concise. 1.01. What is the ratio of the % of value added in manufacturing of Nicaragua in 1976 to that in 1978?
Offer a terse response. 0.95. What is the ratio of the % of value added in manufacturing in Trinidad and Tobago in 1976 to that in 1978?
Make the answer very short. 0.84. What is the ratio of the % of value added in manufacturing in Austria in 1976 to that in 1979?
Provide a short and direct response. 1.04. What is the ratio of the % of value added in manufacturing of El Salvador in 1976 to that in 1979?
Keep it short and to the point. 0.84. What is the ratio of the % of value added in manufacturing in Nicaragua in 1976 to that in 1979?
Keep it short and to the point. 0.96. What is the ratio of the % of value added in manufacturing in Trinidad and Tobago in 1976 to that in 1979?
Your answer should be compact. 0.89. What is the ratio of the % of value added in manufacturing in Austria in 1976 to that in 1980?
Provide a succinct answer. 1.07. What is the ratio of the % of value added in manufacturing of El Salvador in 1976 to that in 1980?
Your answer should be compact. 0.75. What is the ratio of the % of value added in manufacturing in Nicaragua in 1976 to that in 1980?
Make the answer very short. 0.97. What is the ratio of the % of value added in manufacturing of Trinidad and Tobago in 1976 to that in 1980?
Offer a very short reply. 0.86. What is the ratio of the % of value added in manufacturing in Austria in 1976 to that in 1981?
Make the answer very short. 1.06. What is the ratio of the % of value added in manufacturing in El Salvador in 1976 to that in 1981?
Provide a succinct answer. 0.76. What is the ratio of the % of value added in manufacturing in Nicaragua in 1976 to that in 1981?
Make the answer very short. 0.93. What is the ratio of the % of value added in manufacturing in Trinidad and Tobago in 1976 to that in 1981?
Provide a short and direct response. 0.6. What is the ratio of the % of value added in manufacturing of Austria in 1976 to that in 1982?
Offer a very short reply. 1.03. What is the ratio of the % of value added in manufacturing in El Salvador in 1976 to that in 1982?
Your response must be concise. 0.74. What is the ratio of the % of value added in manufacturing in Nicaragua in 1976 to that in 1982?
Provide a short and direct response. 0.91. What is the ratio of the % of value added in manufacturing of Trinidad and Tobago in 1976 to that in 1982?
Make the answer very short. 0.54. What is the ratio of the % of value added in manufacturing of Austria in 1976 to that in 1983?
Provide a succinct answer. 1.01. What is the ratio of the % of value added in manufacturing in El Salvador in 1976 to that in 1983?
Your answer should be very brief. 0.78. What is the ratio of the % of value added in manufacturing in Nicaragua in 1976 to that in 1983?
Your response must be concise. 0.91. What is the ratio of the % of value added in manufacturing of Trinidad and Tobago in 1976 to that in 1983?
Provide a short and direct response. 0.58. What is the ratio of the % of value added in manufacturing in Austria in 1977 to that in 1978?
Your answer should be very brief. 1.03. What is the ratio of the % of value added in manufacturing in El Salvador in 1977 to that in 1978?
Ensure brevity in your answer.  0.94. What is the ratio of the % of value added in manufacturing of Nicaragua in 1977 to that in 1978?
Ensure brevity in your answer.  0.93. What is the ratio of the % of value added in manufacturing in Trinidad and Tobago in 1977 to that in 1978?
Offer a very short reply. 0.94. What is the ratio of the % of value added in manufacturing in Austria in 1977 to that in 1979?
Your response must be concise. 1.05. What is the ratio of the % of value added in manufacturing of El Salvador in 1977 to that in 1979?
Make the answer very short. 0.78. What is the ratio of the % of value added in manufacturing of Nicaragua in 1977 to that in 1979?
Give a very brief answer. 0.94. What is the ratio of the % of value added in manufacturing of Austria in 1977 to that in 1980?
Make the answer very short. 1.09. What is the ratio of the % of value added in manufacturing in El Salvador in 1977 to that in 1980?
Offer a terse response. 0.7. What is the ratio of the % of value added in manufacturing of Nicaragua in 1977 to that in 1980?
Provide a short and direct response. 0.95. What is the ratio of the % of value added in manufacturing of Trinidad and Tobago in 1977 to that in 1980?
Ensure brevity in your answer.  0.97. What is the ratio of the % of value added in manufacturing in Austria in 1977 to that in 1981?
Make the answer very short. 1.08. What is the ratio of the % of value added in manufacturing of El Salvador in 1977 to that in 1981?
Offer a very short reply. 0.71. What is the ratio of the % of value added in manufacturing in Nicaragua in 1977 to that in 1981?
Offer a terse response. 0.91. What is the ratio of the % of value added in manufacturing in Trinidad and Tobago in 1977 to that in 1981?
Offer a very short reply. 0.68. What is the ratio of the % of value added in manufacturing of Austria in 1977 to that in 1982?
Your response must be concise. 1.04. What is the ratio of the % of value added in manufacturing in El Salvador in 1977 to that in 1982?
Offer a very short reply. 0.69. What is the ratio of the % of value added in manufacturing of Nicaragua in 1977 to that in 1982?
Your answer should be compact. 0.89. What is the ratio of the % of value added in manufacturing in Trinidad and Tobago in 1977 to that in 1982?
Provide a succinct answer. 0.61. What is the ratio of the % of value added in manufacturing in Austria in 1977 to that in 1983?
Keep it short and to the point. 1.03. What is the ratio of the % of value added in manufacturing of El Salvador in 1977 to that in 1983?
Ensure brevity in your answer.  0.72. What is the ratio of the % of value added in manufacturing in Nicaragua in 1977 to that in 1983?
Keep it short and to the point. 0.89. What is the ratio of the % of value added in manufacturing in Trinidad and Tobago in 1977 to that in 1983?
Your answer should be very brief. 0.65. What is the ratio of the % of value added in manufacturing in Austria in 1978 to that in 1979?
Keep it short and to the point. 1.03. What is the ratio of the % of value added in manufacturing of El Salvador in 1978 to that in 1979?
Your response must be concise. 0.83. What is the ratio of the % of value added in manufacturing in Nicaragua in 1978 to that in 1979?
Provide a short and direct response. 1.01. What is the ratio of the % of value added in manufacturing of Trinidad and Tobago in 1978 to that in 1979?
Provide a short and direct response. 1.06. What is the ratio of the % of value added in manufacturing of Austria in 1978 to that in 1980?
Offer a very short reply. 1.06. What is the ratio of the % of value added in manufacturing of El Salvador in 1978 to that in 1980?
Ensure brevity in your answer.  0.74. What is the ratio of the % of value added in manufacturing of Nicaragua in 1978 to that in 1980?
Offer a very short reply. 1.02. What is the ratio of the % of value added in manufacturing of Trinidad and Tobago in 1978 to that in 1980?
Make the answer very short. 1.03. What is the ratio of the % of value added in manufacturing in Austria in 1978 to that in 1981?
Offer a terse response. 1.05. What is the ratio of the % of value added in manufacturing in El Salvador in 1978 to that in 1981?
Make the answer very short. 0.75. What is the ratio of the % of value added in manufacturing in Nicaragua in 1978 to that in 1981?
Keep it short and to the point. 0.98. What is the ratio of the % of value added in manufacturing of Trinidad and Tobago in 1978 to that in 1981?
Provide a succinct answer. 0.72. What is the ratio of the % of value added in manufacturing of Austria in 1978 to that in 1982?
Offer a very short reply. 1.02. What is the ratio of the % of value added in manufacturing in El Salvador in 1978 to that in 1982?
Make the answer very short. 0.73. What is the ratio of the % of value added in manufacturing of Nicaragua in 1978 to that in 1982?
Your answer should be compact. 0.95. What is the ratio of the % of value added in manufacturing of Trinidad and Tobago in 1978 to that in 1982?
Provide a succinct answer. 0.65. What is the ratio of the % of value added in manufacturing in Austria in 1978 to that in 1983?
Provide a succinct answer. 1. What is the ratio of the % of value added in manufacturing of El Salvador in 1978 to that in 1983?
Provide a succinct answer. 0.77. What is the ratio of the % of value added in manufacturing of Nicaragua in 1978 to that in 1983?
Offer a terse response. 0.95. What is the ratio of the % of value added in manufacturing in Trinidad and Tobago in 1978 to that in 1983?
Provide a succinct answer. 0.69. What is the ratio of the % of value added in manufacturing of Austria in 1979 to that in 1980?
Offer a terse response. 1.03. What is the ratio of the % of value added in manufacturing of El Salvador in 1979 to that in 1980?
Provide a succinct answer. 0.9. What is the ratio of the % of value added in manufacturing in Nicaragua in 1979 to that in 1980?
Make the answer very short. 1.01. What is the ratio of the % of value added in manufacturing of Trinidad and Tobago in 1979 to that in 1980?
Your answer should be very brief. 0.97. What is the ratio of the % of value added in manufacturing in Austria in 1979 to that in 1981?
Make the answer very short. 1.02. What is the ratio of the % of value added in manufacturing in El Salvador in 1979 to that in 1981?
Provide a succinct answer. 0.91. What is the ratio of the % of value added in manufacturing of Nicaragua in 1979 to that in 1981?
Make the answer very short. 0.97. What is the ratio of the % of value added in manufacturing in Trinidad and Tobago in 1979 to that in 1981?
Offer a terse response. 0.68. What is the ratio of the % of value added in manufacturing in Austria in 1979 to that in 1982?
Keep it short and to the point. 0.99. What is the ratio of the % of value added in manufacturing of El Salvador in 1979 to that in 1982?
Offer a terse response. 0.89. What is the ratio of the % of value added in manufacturing of Nicaragua in 1979 to that in 1982?
Provide a short and direct response. 0.95. What is the ratio of the % of value added in manufacturing in Trinidad and Tobago in 1979 to that in 1982?
Give a very brief answer. 0.61. What is the ratio of the % of value added in manufacturing in Austria in 1979 to that in 1983?
Make the answer very short. 0.97. What is the ratio of the % of value added in manufacturing of El Salvador in 1979 to that in 1983?
Make the answer very short. 0.93. What is the ratio of the % of value added in manufacturing in Nicaragua in 1979 to that in 1983?
Your answer should be very brief. 0.95. What is the ratio of the % of value added in manufacturing in Trinidad and Tobago in 1979 to that in 1983?
Give a very brief answer. 0.66. What is the ratio of the % of value added in manufacturing of Austria in 1980 to that in 1981?
Offer a very short reply. 0.99. What is the ratio of the % of value added in manufacturing of El Salvador in 1980 to that in 1981?
Keep it short and to the point. 1.01. What is the ratio of the % of value added in manufacturing of Nicaragua in 1980 to that in 1981?
Provide a short and direct response. 0.96. What is the ratio of the % of value added in manufacturing in Trinidad and Tobago in 1980 to that in 1981?
Give a very brief answer. 0.7. What is the ratio of the % of value added in manufacturing of Austria in 1980 to that in 1982?
Provide a succinct answer. 0.96. What is the ratio of the % of value added in manufacturing in El Salvador in 1980 to that in 1982?
Provide a short and direct response. 0.99. What is the ratio of the % of value added in manufacturing of Nicaragua in 1980 to that in 1982?
Offer a terse response. 0.94. What is the ratio of the % of value added in manufacturing in Trinidad and Tobago in 1980 to that in 1982?
Your answer should be compact. 0.63. What is the ratio of the % of value added in manufacturing of El Salvador in 1980 to that in 1983?
Give a very brief answer. 1.03. What is the ratio of the % of value added in manufacturing in Nicaragua in 1980 to that in 1983?
Offer a very short reply. 0.94. What is the ratio of the % of value added in manufacturing in Trinidad and Tobago in 1980 to that in 1983?
Provide a short and direct response. 0.67. What is the ratio of the % of value added in manufacturing of Austria in 1981 to that in 1982?
Offer a terse response. 0.97. What is the ratio of the % of value added in manufacturing in El Salvador in 1981 to that in 1982?
Keep it short and to the point. 0.97. What is the ratio of the % of value added in manufacturing of Nicaragua in 1981 to that in 1982?
Make the answer very short. 0.97. What is the ratio of the % of value added in manufacturing of Trinidad and Tobago in 1981 to that in 1982?
Keep it short and to the point. 0.9. What is the ratio of the % of value added in manufacturing of Austria in 1981 to that in 1983?
Your response must be concise. 0.95. What is the ratio of the % of value added in manufacturing in El Salvador in 1981 to that in 1983?
Ensure brevity in your answer.  1.02. What is the ratio of the % of value added in manufacturing in Nicaragua in 1981 to that in 1983?
Your response must be concise. 0.97. What is the ratio of the % of value added in manufacturing of Trinidad and Tobago in 1981 to that in 1983?
Provide a short and direct response. 0.96. What is the ratio of the % of value added in manufacturing of Austria in 1982 to that in 1983?
Offer a terse response. 0.98. What is the ratio of the % of value added in manufacturing in El Salvador in 1982 to that in 1983?
Make the answer very short. 1.05. What is the ratio of the % of value added in manufacturing of Trinidad and Tobago in 1982 to that in 1983?
Provide a short and direct response. 1.07. What is the difference between the highest and the second highest % of value added in manufacturing in Austria?
Ensure brevity in your answer.  0.27. What is the difference between the highest and the second highest % of value added in manufacturing of El Salvador?
Keep it short and to the point. 0.52. What is the difference between the highest and the second highest % of value added in manufacturing in Nicaragua?
Give a very brief answer. 0. What is the difference between the highest and the second highest % of value added in manufacturing of Trinidad and Tobago?
Your answer should be very brief. 2.25. What is the difference between the highest and the lowest % of value added in manufacturing in Austria?
Ensure brevity in your answer.  1.41. What is the difference between the highest and the lowest % of value added in manufacturing of El Salvador?
Offer a terse response. 11.78. What is the difference between the highest and the lowest % of value added in manufacturing in Nicaragua?
Keep it short and to the point. 6.12. What is the difference between the highest and the lowest % of value added in manufacturing of Trinidad and Tobago?
Offer a terse response. 16.08. 